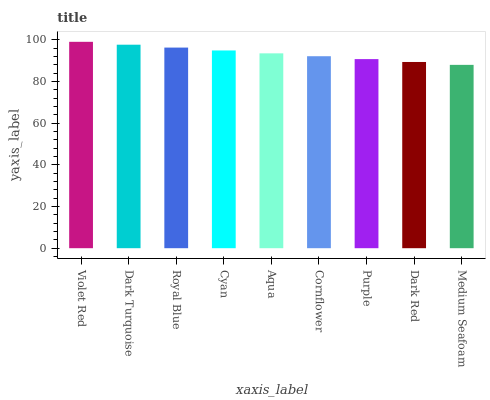Is Dark Turquoise the minimum?
Answer yes or no. No. Is Dark Turquoise the maximum?
Answer yes or no. No. Is Violet Red greater than Dark Turquoise?
Answer yes or no. Yes. Is Dark Turquoise less than Violet Red?
Answer yes or no. Yes. Is Dark Turquoise greater than Violet Red?
Answer yes or no. No. Is Violet Red less than Dark Turquoise?
Answer yes or no. No. Is Aqua the high median?
Answer yes or no. Yes. Is Aqua the low median?
Answer yes or no. Yes. Is Cyan the high median?
Answer yes or no. No. Is Dark Turquoise the low median?
Answer yes or no. No. 